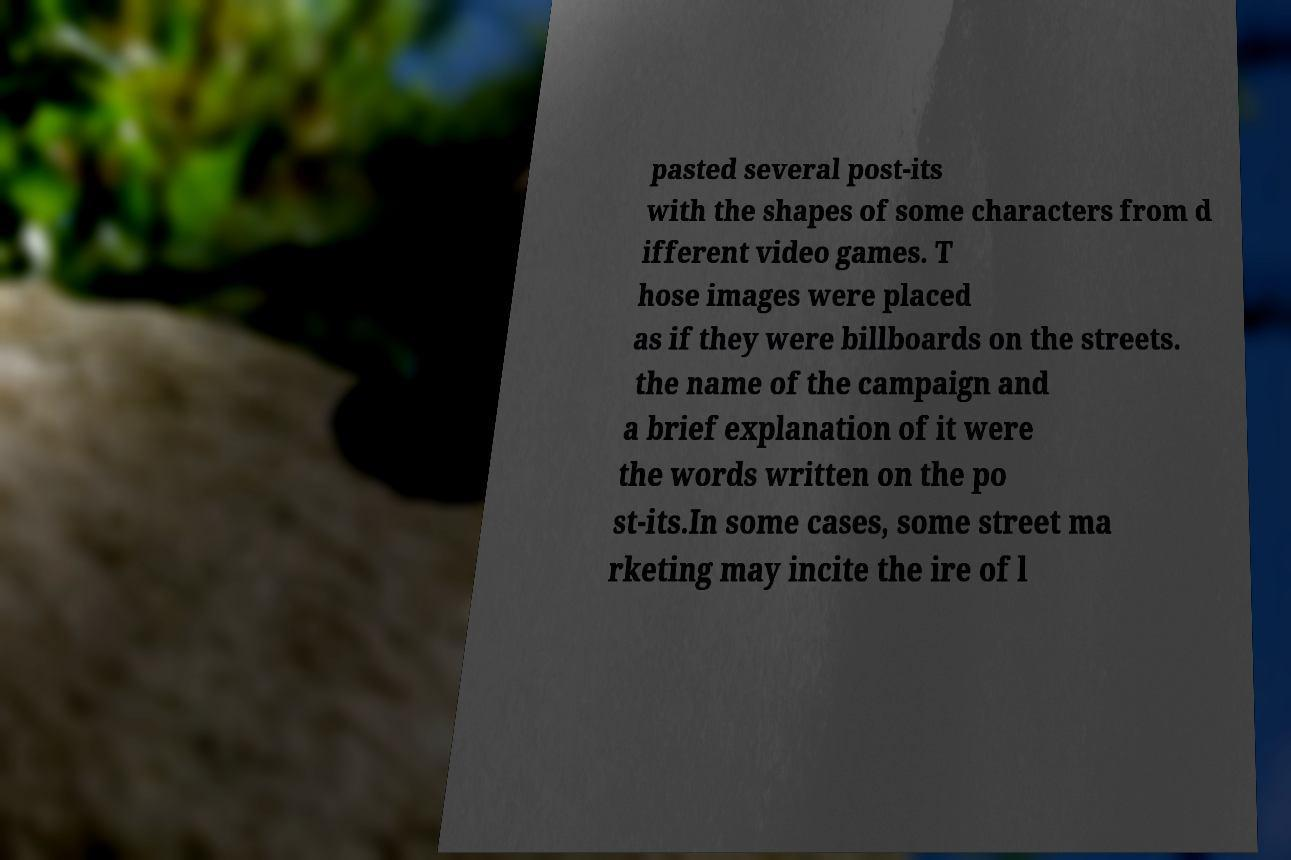Could you assist in decoding the text presented in this image and type it out clearly? pasted several post-its with the shapes of some characters from d ifferent video games. T hose images were placed as if they were billboards on the streets. the name of the campaign and a brief explanation of it were the words written on the po st-its.In some cases, some street ma rketing may incite the ire of l 